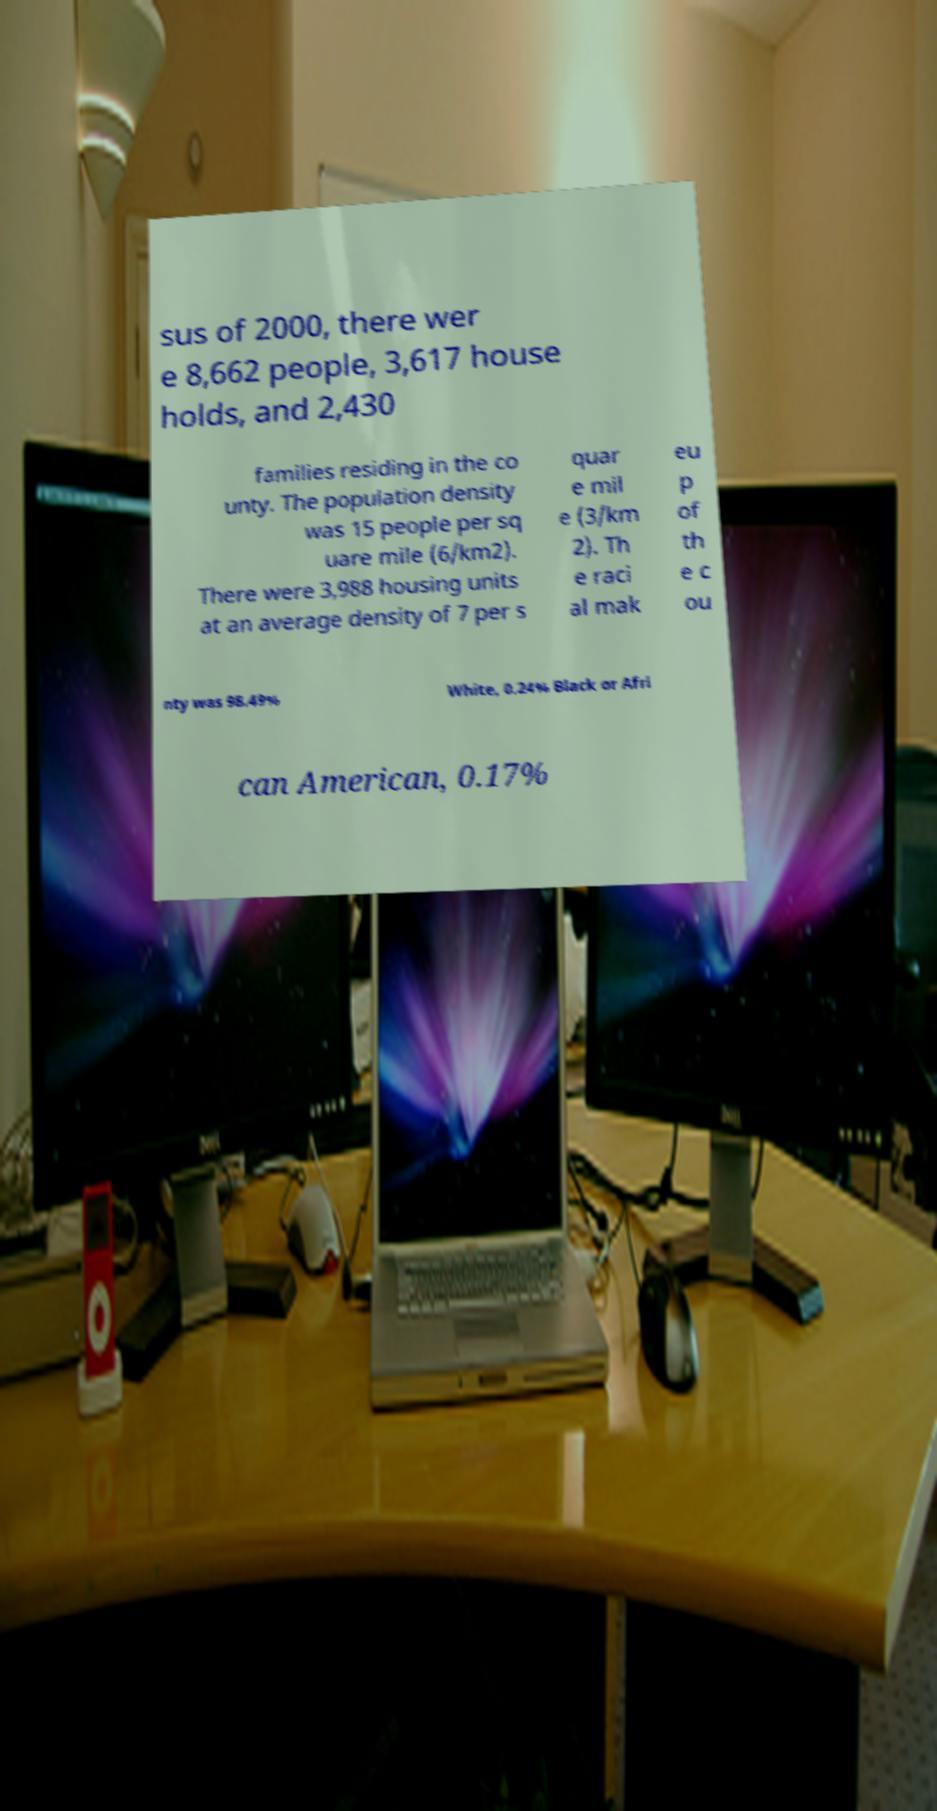For documentation purposes, I need the text within this image transcribed. Could you provide that? sus of 2000, there wer e 8,662 people, 3,617 house holds, and 2,430 families residing in the co unty. The population density was 15 people per sq uare mile (6/km2). There were 3,988 housing units at an average density of 7 per s quar e mil e (3/km 2). Th e raci al mak eu p of th e c ou nty was 98.49% White, 0.24% Black or Afri can American, 0.17% 